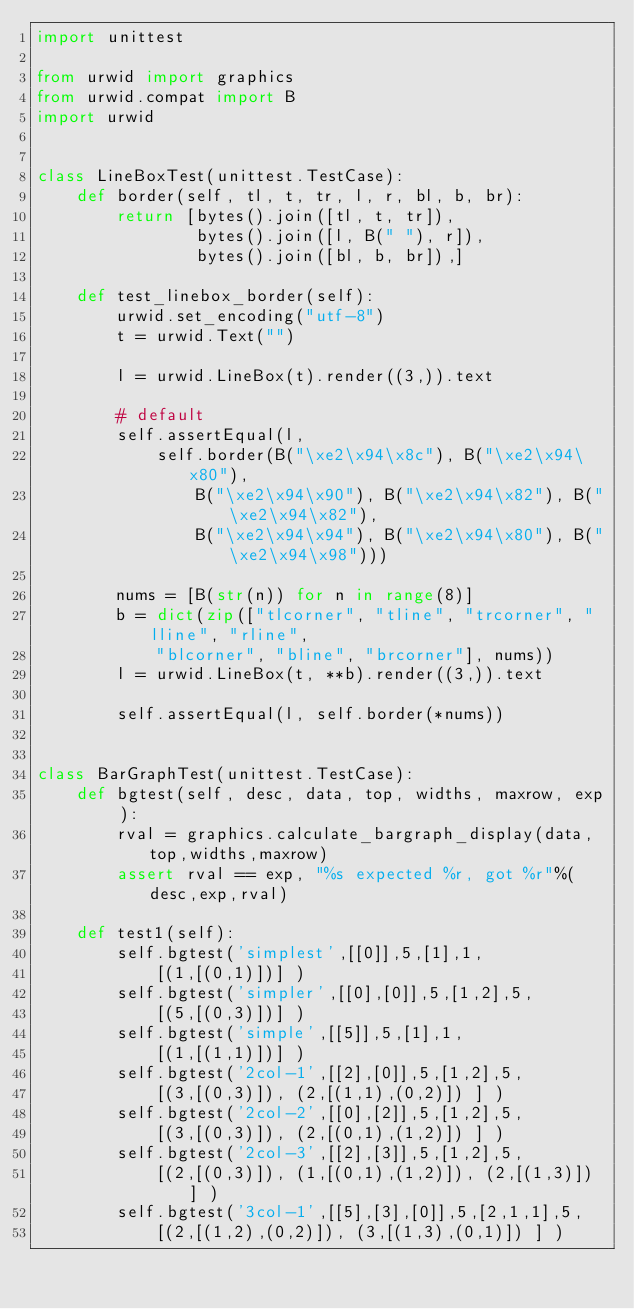Convert code to text. <code><loc_0><loc_0><loc_500><loc_500><_Python_>import unittest

from urwid import graphics
from urwid.compat import B
import urwid


class LineBoxTest(unittest.TestCase):
    def border(self, tl, t, tr, l, r, bl, b, br):
        return [bytes().join([tl, t, tr]),
                bytes().join([l, B(" "), r]),
                bytes().join([bl, b, br]),]

    def test_linebox_border(self):
        urwid.set_encoding("utf-8")
        t = urwid.Text("")

        l = urwid.LineBox(t).render((3,)).text

        # default
        self.assertEqual(l,
            self.border(B("\xe2\x94\x8c"), B("\xe2\x94\x80"),
                B("\xe2\x94\x90"), B("\xe2\x94\x82"), B("\xe2\x94\x82"),
                B("\xe2\x94\x94"), B("\xe2\x94\x80"), B("\xe2\x94\x98")))

        nums = [B(str(n)) for n in range(8)]
        b = dict(zip(["tlcorner", "tline", "trcorner", "lline", "rline",
            "blcorner", "bline", "brcorner"], nums))
        l = urwid.LineBox(t, **b).render((3,)).text

        self.assertEqual(l, self.border(*nums))


class BarGraphTest(unittest.TestCase):
    def bgtest(self, desc, data, top, widths, maxrow, exp ):
        rval = graphics.calculate_bargraph_display(data,top,widths,maxrow)
        assert rval == exp, "%s expected %r, got %r"%(desc,exp,rval)

    def test1(self):
        self.bgtest('simplest',[[0]],5,[1],1,
            [(1,[(0,1)])] )
        self.bgtest('simpler',[[0],[0]],5,[1,2],5,
            [(5,[(0,3)])] )
        self.bgtest('simple',[[5]],5,[1],1,
            [(1,[(1,1)])] )
        self.bgtest('2col-1',[[2],[0]],5,[1,2],5,
            [(3,[(0,3)]), (2,[(1,1),(0,2)]) ] )
        self.bgtest('2col-2',[[0],[2]],5,[1,2],5,
            [(3,[(0,3)]), (2,[(0,1),(1,2)]) ] )
        self.bgtest('2col-3',[[2],[3]],5,[1,2],5,
            [(2,[(0,3)]), (1,[(0,1),(1,2)]), (2,[(1,3)]) ] )
        self.bgtest('3col-1',[[5],[3],[0]],5,[2,1,1],5,
            [(2,[(1,2),(0,2)]), (3,[(1,3),(0,1)]) ] )</code> 